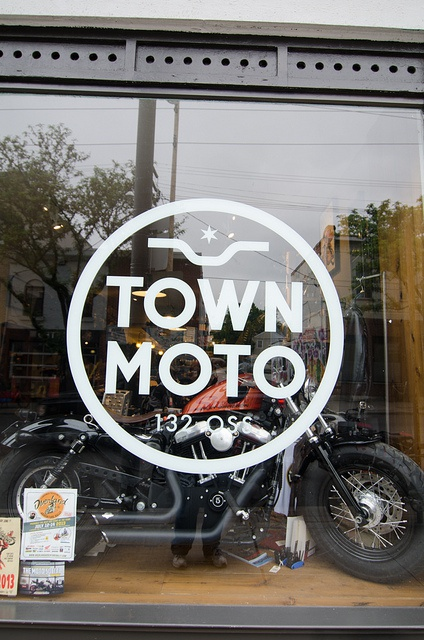Describe the objects in this image and their specific colors. I can see motorcycle in lightgray, black, gray, white, and darkgray tones and people in lightgray, black, and gray tones in this image. 